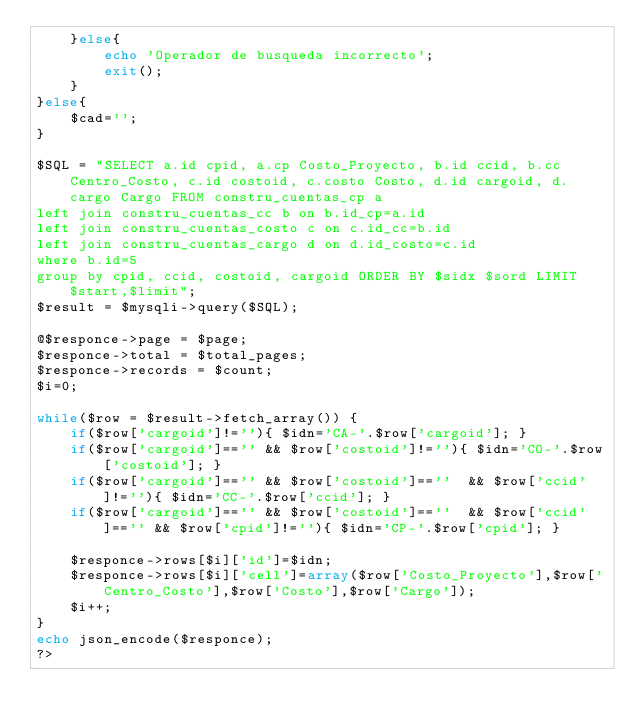<code> <loc_0><loc_0><loc_500><loc_500><_PHP_>    }else{
        echo 'Operador de busqueda incorrecto';
        exit();
    }
}else{
    $cad='';
}

$SQL = "SELECT a.id cpid, a.cp Costo_Proyecto, b.id ccid, b.cc Centro_Costo, c.id costoid, c.costo Costo, d.id cargoid, d.cargo Cargo FROM constru_cuentas_cp a
left join constru_cuentas_cc b on b.id_cp=a.id
left join constru_cuentas_costo c on c.id_cc=b.id
left join constru_cuentas_cargo d on d.id_costo=c.id
where b.id=5
group by cpid, ccid, costoid, cargoid ORDER BY $sidx $sord LIMIT $start,$limit";
$result = $mysqli->query($SQL);

@$responce->page = $page;
$responce->total = $total_pages;
$responce->records = $count;
$i=0;

while($row = $result->fetch_array()) {
    if($row['cargoid']!=''){ $idn='CA-'.$row['cargoid']; }
    if($row['cargoid']=='' && $row['costoid']!=''){ $idn='CO-'.$row['costoid']; }
    if($row['cargoid']=='' && $row['costoid']==''  && $row['ccid']!=''){ $idn='CC-'.$row['ccid']; }
    if($row['cargoid']=='' && $row['costoid']==''  && $row['ccid']=='' && $row['cpid']!=''){ $idn='CP-'.$row['cpid']; }
 
    $responce->rows[$i]['id']=$idn;
    $responce->rows[$i]['cell']=array($row['Costo_Proyecto'],$row['Centro_Costo'],$row['Costo'],$row['Cargo']);
    $i++;
}        
echo json_encode($responce);
?></code> 